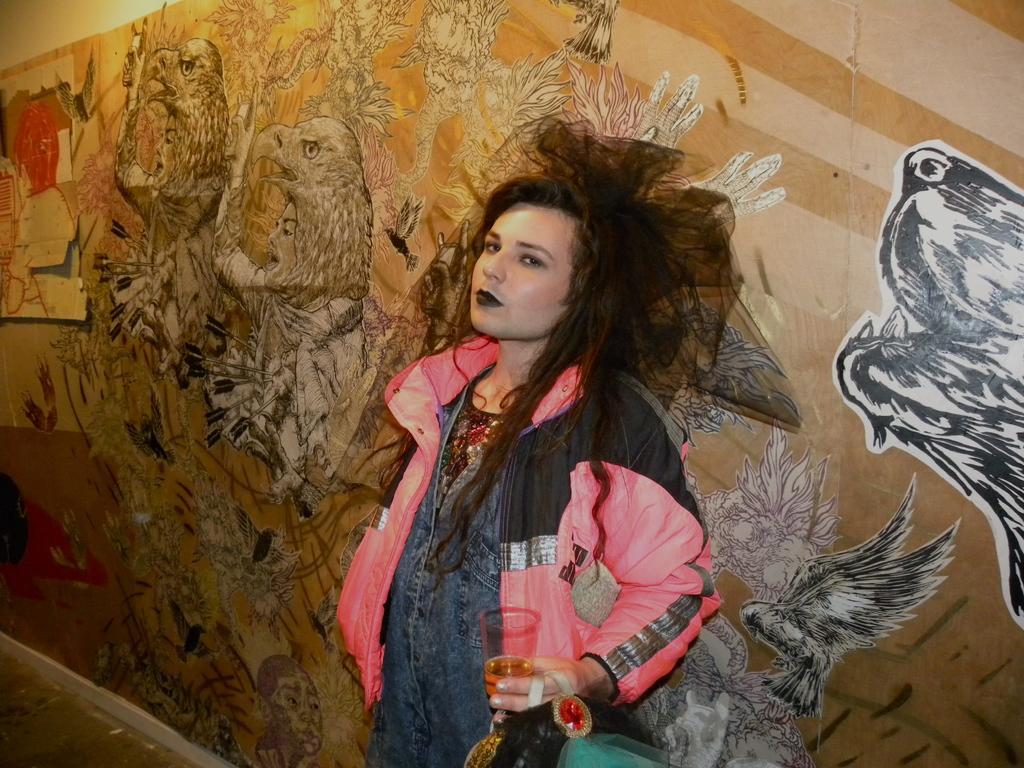Please provide a concise description of this image. In the picture we can see a woman wearing jacket, holding glass in her hands, standing near the wall and we can see wall is painted with some pictures. 